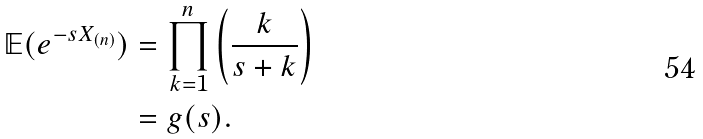Convert formula to latex. <formula><loc_0><loc_0><loc_500><loc_500>\mathbb { E } ( e ^ { - s X _ { ( n ) } } ) & = \prod _ { k = 1 } ^ { n } \left ( \frac { k } { s + k } \right ) \\ & = g ( s ) .</formula> 